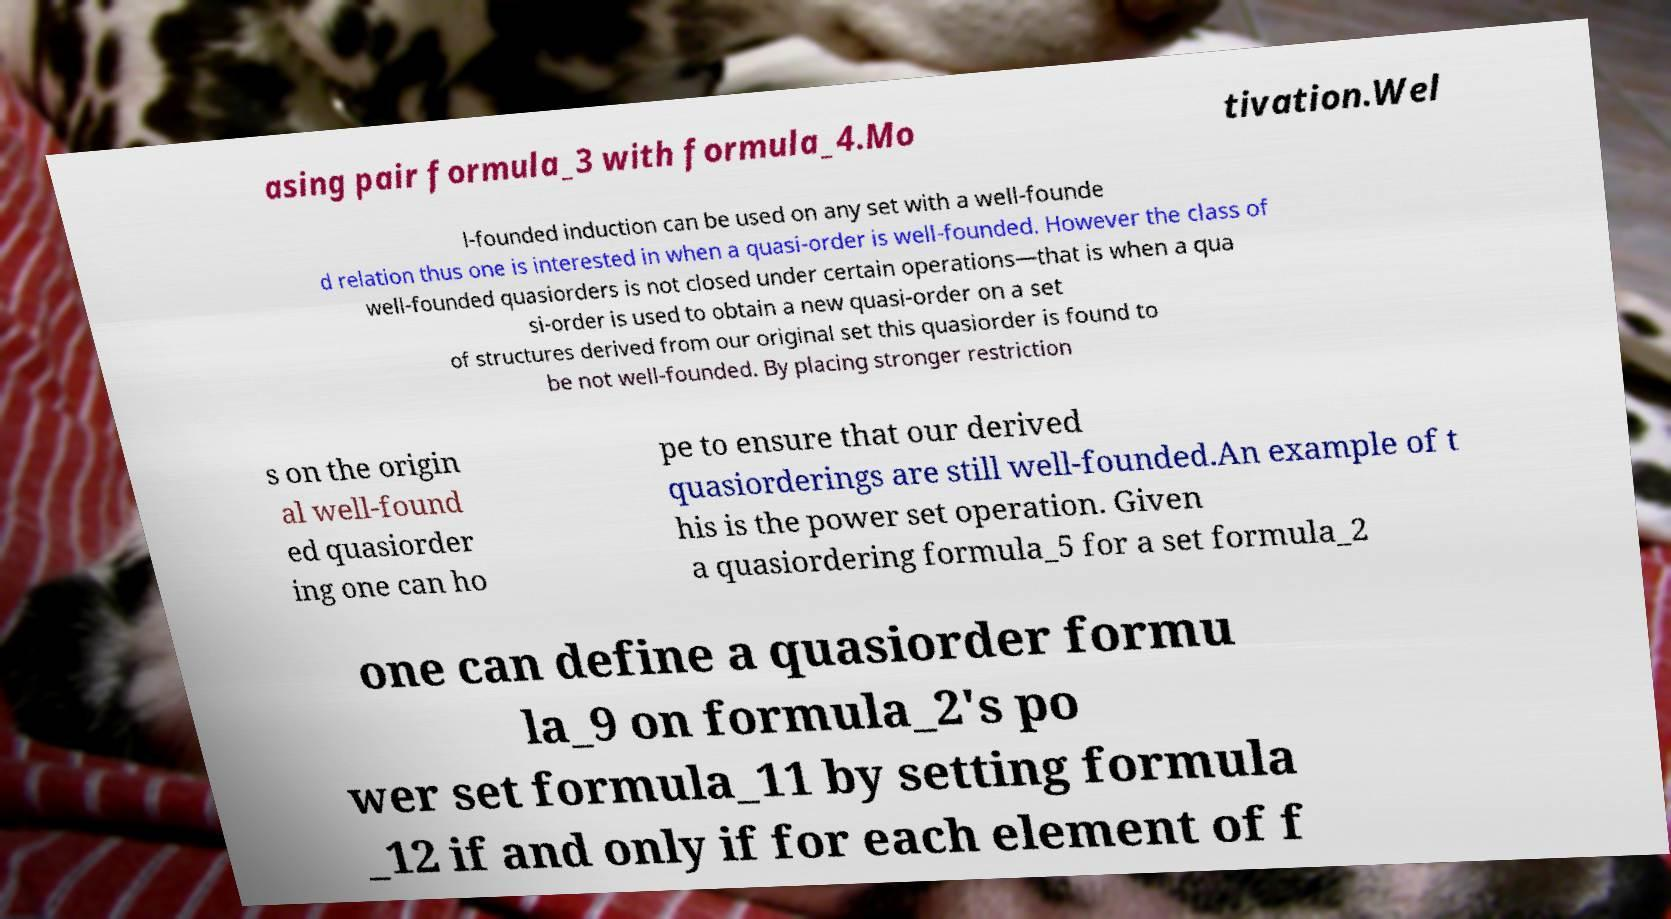Please identify and transcribe the text found in this image. asing pair formula_3 with formula_4.Mo tivation.Wel l-founded induction can be used on any set with a well-founde d relation thus one is interested in when a quasi-order is well-founded. However the class of well-founded quasiorders is not closed under certain operations—that is when a qua si-order is used to obtain a new quasi-order on a set of structures derived from our original set this quasiorder is found to be not well-founded. By placing stronger restriction s on the origin al well-found ed quasiorder ing one can ho pe to ensure that our derived quasiorderings are still well-founded.An example of t his is the power set operation. Given a quasiordering formula_5 for a set formula_2 one can define a quasiorder formu la_9 on formula_2's po wer set formula_11 by setting formula _12 if and only if for each element of f 